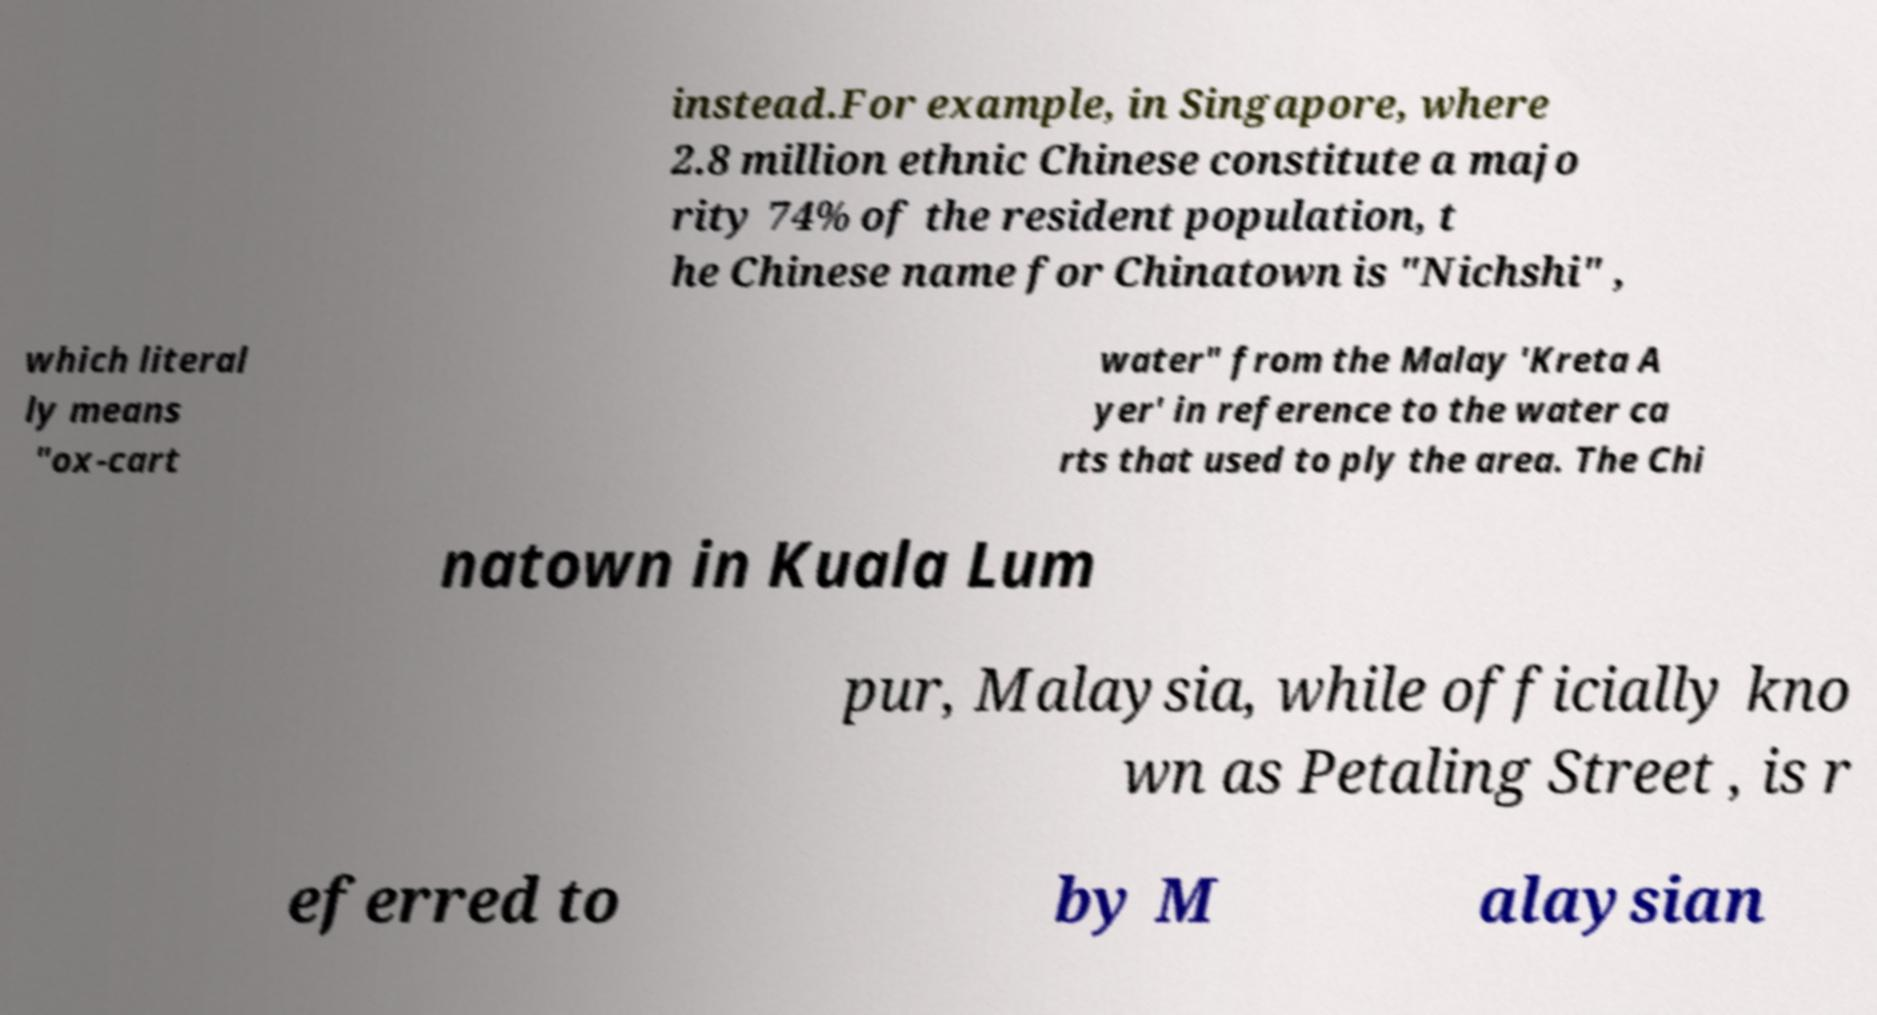Could you extract and type out the text from this image? instead.For example, in Singapore, where 2.8 million ethnic Chinese constitute a majo rity 74% of the resident population, t he Chinese name for Chinatown is "Nichshi" , which literal ly means "ox-cart water" from the Malay 'Kreta A yer' in reference to the water ca rts that used to ply the area. The Chi natown in Kuala Lum pur, Malaysia, while officially kno wn as Petaling Street , is r eferred to by M alaysian 